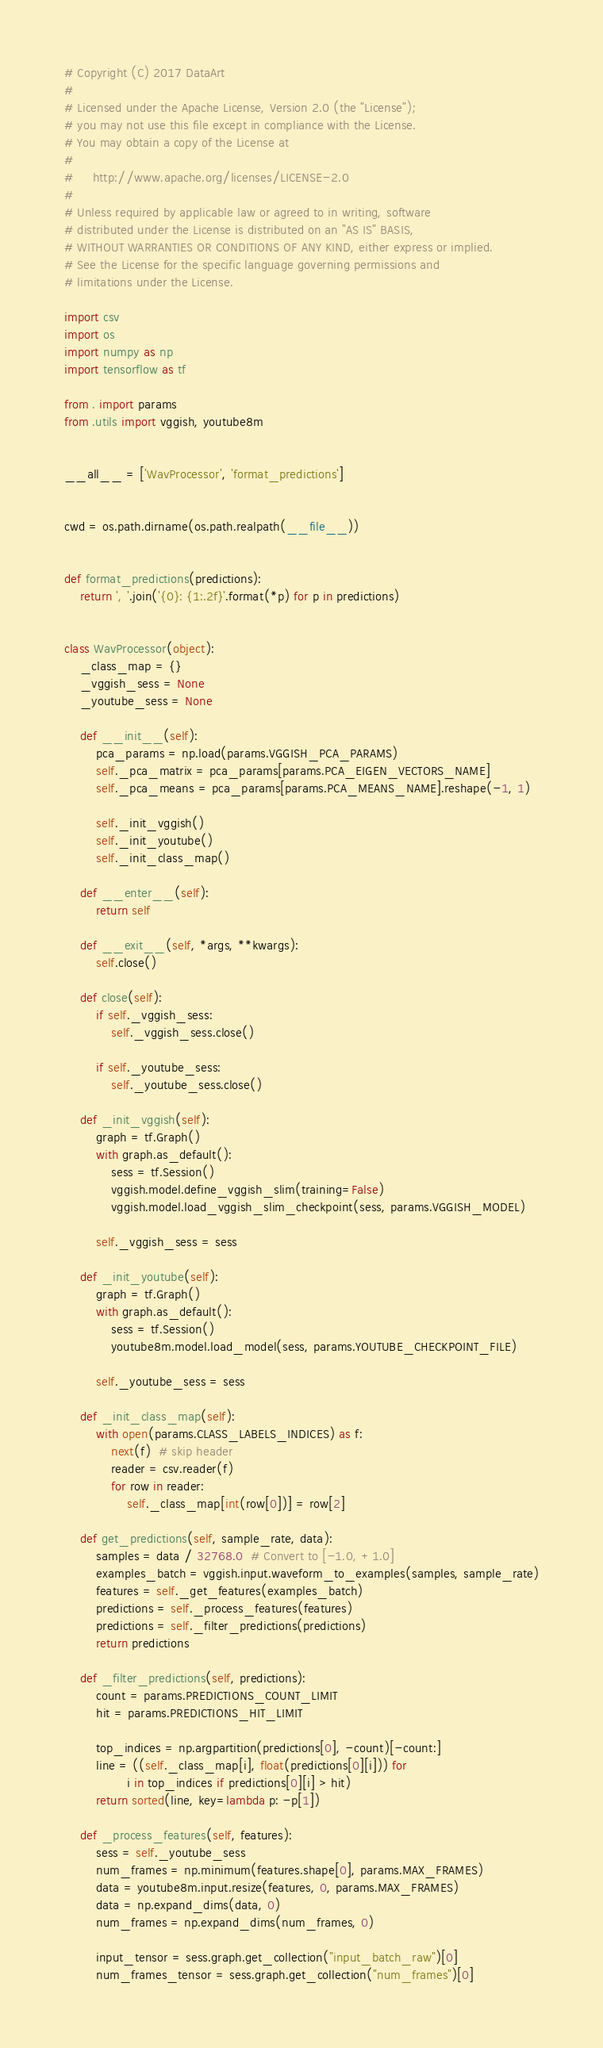Convert code to text. <code><loc_0><loc_0><loc_500><loc_500><_Python_># Copyright (C) 2017 DataArt
#
# Licensed under the Apache License, Version 2.0 (the "License");
# you may not use this file except in compliance with the License.
# You may obtain a copy of the License at
#
#     http://www.apache.org/licenses/LICENSE-2.0
#
# Unless required by applicable law or agreed to in writing, software
# distributed under the License is distributed on an "AS IS" BASIS,
# WITHOUT WARRANTIES OR CONDITIONS OF ANY KIND, either express or implied.
# See the License for the specific language governing permissions and
# limitations under the License.

import csv
import os
import numpy as np
import tensorflow as tf

from . import params
from .utils import vggish, youtube8m


__all__ = ['WavProcessor', 'format_predictions']


cwd = os.path.dirname(os.path.realpath(__file__))


def format_predictions(predictions):
    return ', '.join('{0}: {1:.2f}'.format(*p) for p in predictions)


class WavProcessor(object):
    _class_map = {}
    _vggish_sess = None
    _youtube_sess = None

    def __init__(self):
        pca_params = np.load(params.VGGISH_PCA_PARAMS)
        self._pca_matrix = pca_params[params.PCA_EIGEN_VECTORS_NAME]
        self._pca_means = pca_params[params.PCA_MEANS_NAME].reshape(-1, 1)

        self._init_vggish()
        self._init_youtube()
        self._init_class_map()

    def __enter__(self):
        return self

    def __exit__(self, *args, **kwargs):
        self.close()

    def close(self):
        if self._vggish_sess:
            self._vggish_sess.close()

        if self._youtube_sess:
            self._youtube_sess.close()

    def _init_vggish(self):
        graph = tf.Graph()
        with graph.as_default():
            sess = tf.Session()
            vggish.model.define_vggish_slim(training=False)
            vggish.model.load_vggish_slim_checkpoint(sess, params.VGGISH_MODEL)

        self._vggish_sess = sess

    def _init_youtube(self):
        graph = tf.Graph()
        with graph.as_default():
            sess = tf.Session()
            youtube8m.model.load_model(sess, params.YOUTUBE_CHECKPOINT_FILE)

        self._youtube_sess = sess

    def _init_class_map(self):
        with open(params.CLASS_LABELS_INDICES) as f:
            next(f)  # skip header
            reader = csv.reader(f)
            for row in reader:
                self._class_map[int(row[0])] = row[2]

    def get_predictions(self, sample_rate, data):
        samples = data / 32768.0  # Convert to [-1.0, +1.0]
        examples_batch = vggish.input.waveform_to_examples(samples, sample_rate)
        features = self._get_features(examples_batch)
        predictions = self._process_features(features)
        predictions = self._filter_predictions(predictions)
        return predictions

    def _filter_predictions(self, predictions):
        count = params.PREDICTIONS_COUNT_LIMIT
        hit = params.PREDICTIONS_HIT_LIMIT

        top_indices = np.argpartition(predictions[0], -count)[-count:]
        line = ((self._class_map[i], float(predictions[0][i])) for
                i in top_indices if predictions[0][i] > hit)
        return sorted(line, key=lambda p: -p[1])

    def _process_features(self, features):
        sess = self._youtube_sess
        num_frames = np.minimum(features.shape[0], params.MAX_FRAMES)
        data = youtube8m.input.resize(features, 0, params.MAX_FRAMES)
        data = np.expand_dims(data, 0)
        num_frames = np.expand_dims(num_frames, 0)

        input_tensor = sess.graph.get_collection("input_batch_raw")[0]
        num_frames_tensor = sess.graph.get_collection("num_frames")[0]</code> 